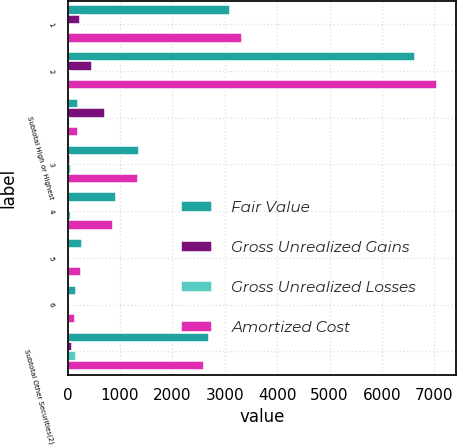<chart> <loc_0><loc_0><loc_500><loc_500><stacked_bar_chart><ecel><fcel>1<fcel>2<fcel>Subtotal High or Highest<fcel>3<fcel>4<fcel>5<fcel>6<fcel>Subtotal Other Securities(2)<nl><fcel>Fair Value<fcel>3091<fcel>6632<fcel>207.5<fcel>1354<fcel>923<fcel>269<fcel>157<fcel>2703<nl><fcel>Gross Unrealized Gains<fcel>247<fcel>467<fcel>714<fcel>55<fcel>12<fcel>4<fcel>5<fcel>76<nl><fcel>Gross Unrealized Losses<fcel>13<fcel>41<fcel>54<fcel>72<fcel>65<fcel>14<fcel>17<fcel>168<nl><fcel>Amortized Cost<fcel>3325<fcel>7058<fcel>207.5<fcel>1337<fcel>870<fcel>259<fcel>145<fcel>2611<nl></chart> 